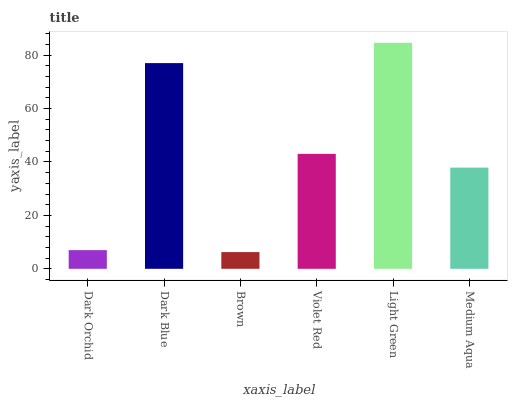Is Brown the minimum?
Answer yes or no. Yes. Is Light Green the maximum?
Answer yes or no. Yes. Is Dark Blue the minimum?
Answer yes or no. No. Is Dark Blue the maximum?
Answer yes or no. No. Is Dark Blue greater than Dark Orchid?
Answer yes or no. Yes. Is Dark Orchid less than Dark Blue?
Answer yes or no. Yes. Is Dark Orchid greater than Dark Blue?
Answer yes or no. No. Is Dark Blue less than Dark Orchid?
Answer yes or no. No. Is Violet Red the high median?
Answer yes or no. Yes. Is Medium Aqua the low median?
Answer yes or no. Yes. Is Light Green the high median?
Answer yes or no. No. Is Dark Blue the low median?
Answer yes or no. No. 